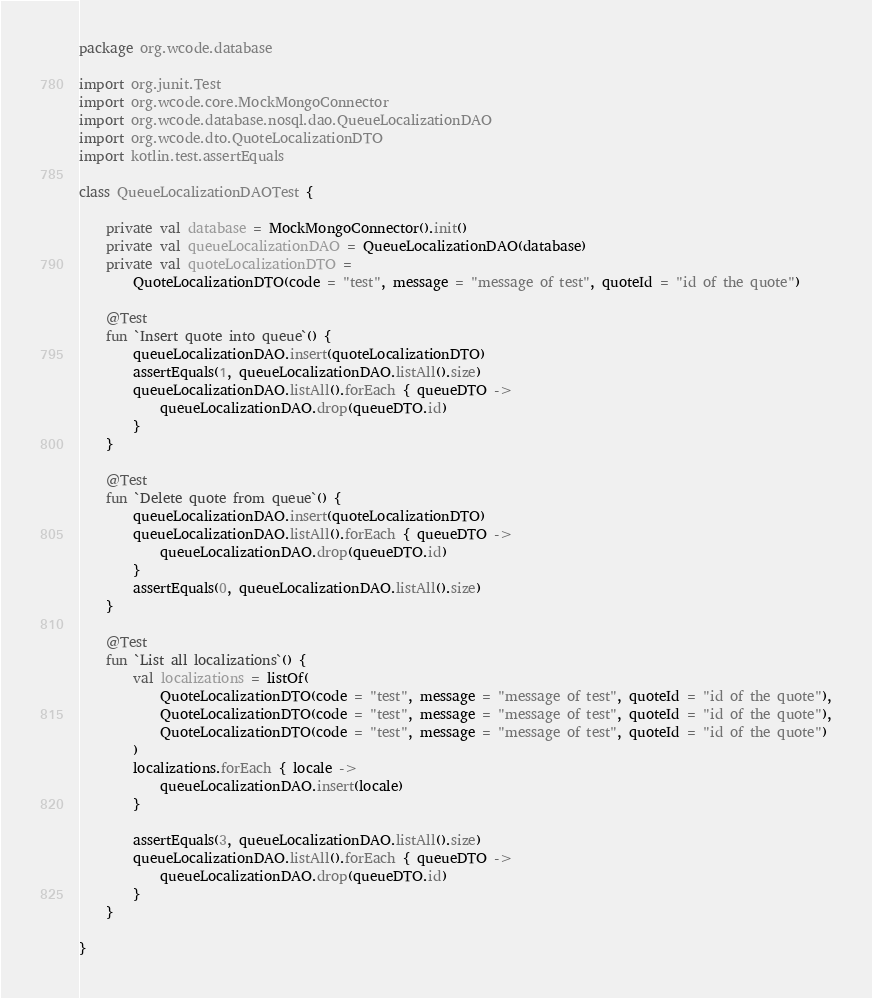Convert code to text. <code><loc_0><loc_0><loc_500><loc_500><_Kotlin_>package org.wcode.database

import org.junit.Test
import org.wcode.core.MockMongoConnector
import org.wcode.database.nosql.dao.QueueLocalizationDAO
import org.wcode.dto.QuoteLocalizationDTO
import kotlin.test.assertEquals

class QueueLocalizationDAOTest {

    private val database = MockMongoConnector().init()
    private val queueLocalizationDAO = QueueLocalizationDAO(database)
    private val quoteLocalizationDTO =
        QuoteLocalizationDTO(code = "test", message = "message of test", quoteId = "id of the quote")

    @Test
    fun `Insert quote into queue`() {
        queueLocalizationDAO.insert(quoteLocalizationDTO)
        assertEquals(1, queueLocalizationDAO.listAll().size)
        queueLocalizationDAO.listAll().forEach { queueDTO ->
            queueLocalizationDAO.drop(queueDTO.id)
        }
    }

    @Test
    fun `Delete quote from queue`() {
        queueLocalizationDAO.insert(quoteLocalizationDTO)
        queueLocalizationDAO.listAll().forEach { queueDTO ->
            queueLocalizationDAO.drop(queueDTO.id)
        }
        assertEquals(0, queueLocalizationDAO.listAll().size)
    }

    @Test
    fun `List all localizations`() {
        val localizations = listOf(
            QuoteLocalizationDTO(code = "test", message = "message of test", quoteId = "id of the quote"),
            QuoteLocalizationDTO(code = "test", message = "message of test", quoteId = "id of the quote"),
            QuoteLocalizationDTO(code = "test", message = "message of test", quoteId = "id of the quote")
        )
        localizations.forEach { locale ->
            queueLocalizationDAO.insert(locale)
        }

        assertEquals(3, queueLocalizationDAO.listAll().size)
        queueLocalizationDAO.listAll().forEach { queueDTO ->
            queueLocalizationDAO.drop(queueDTO.id)
        }
    }

}
</code> 